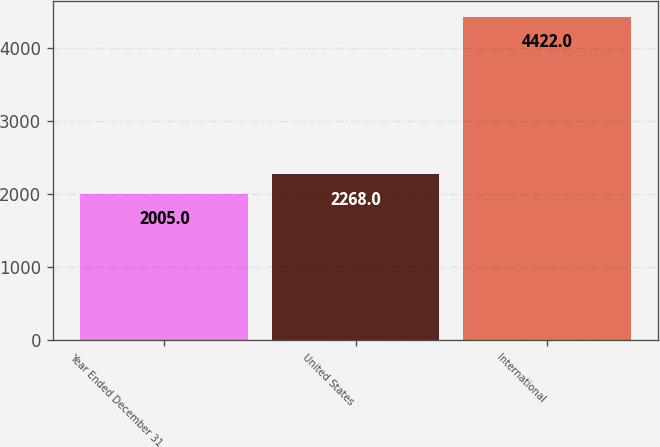Convert chart. <chart><loc_0><loc_0><loc_500><loc_500><bar_chart><fcel>Year Ended December 31<fcel>United States<fcel>International<nl><fcel>2005<fcel>2268<fcel>4422<nl></chart> 